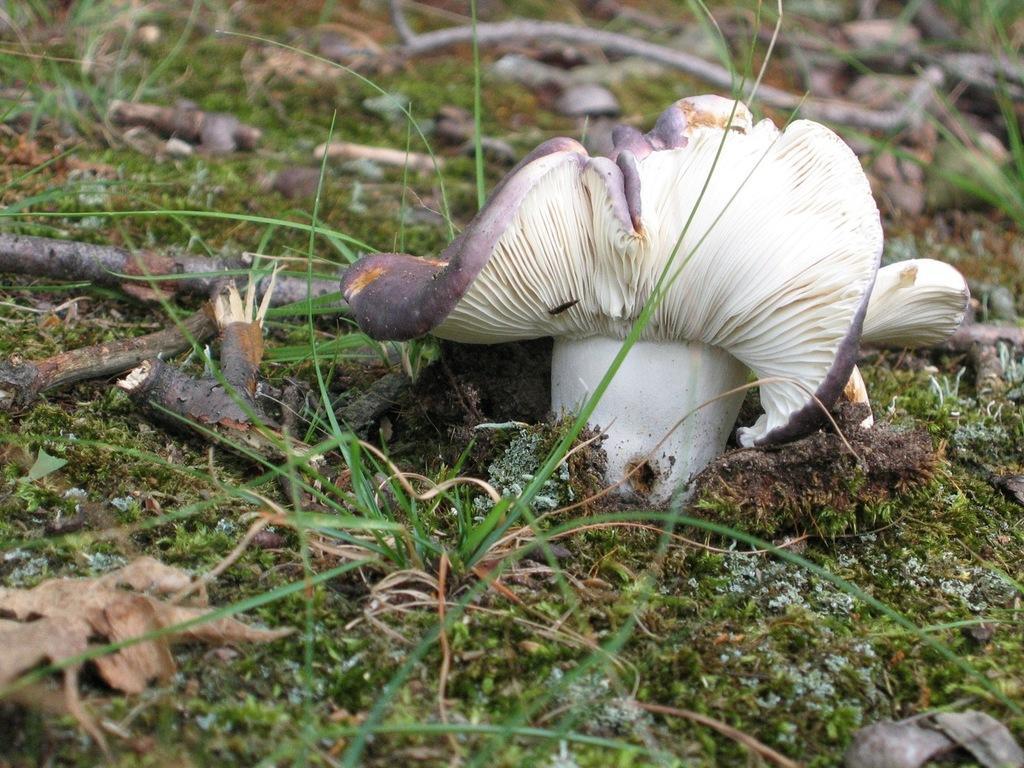How would you summarize this image in a sentence or two? In the picture we can see a grass surface on it we can see some sticks, and mushroom from the ground which is cream in color and some part is white in color. 